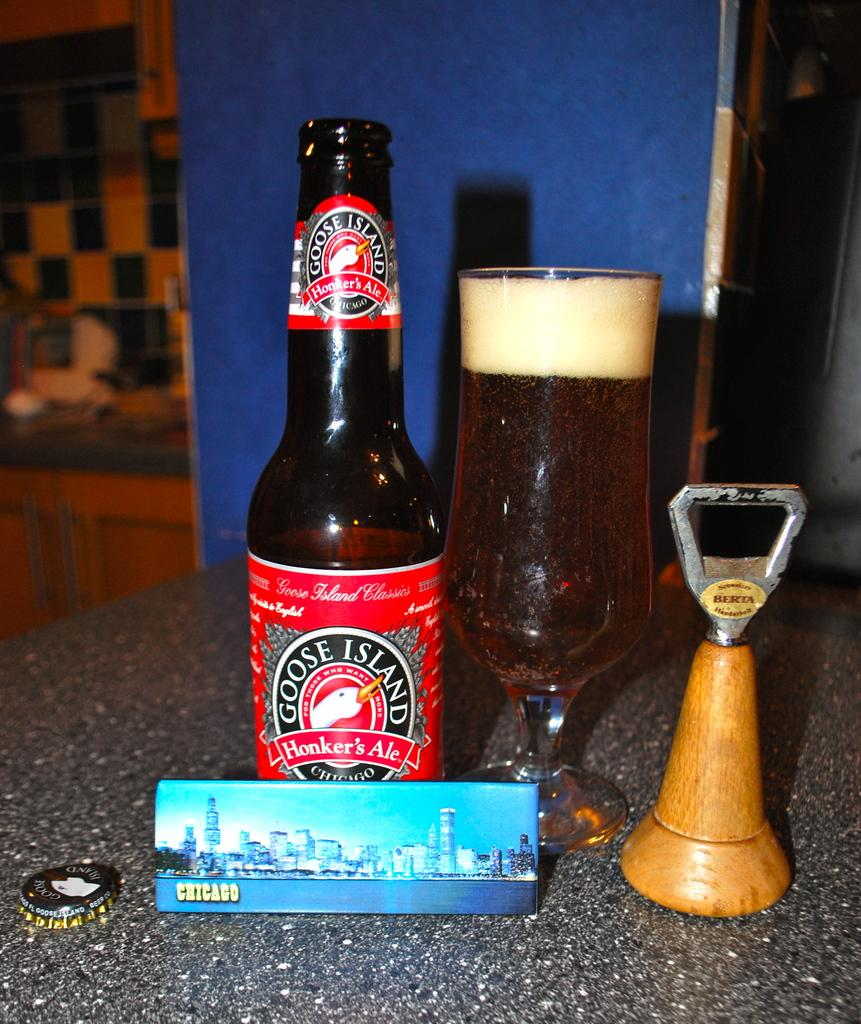<image>
Provide a brief description of the given image. A Goose Island Honker's ale bottle next to a glass of it 